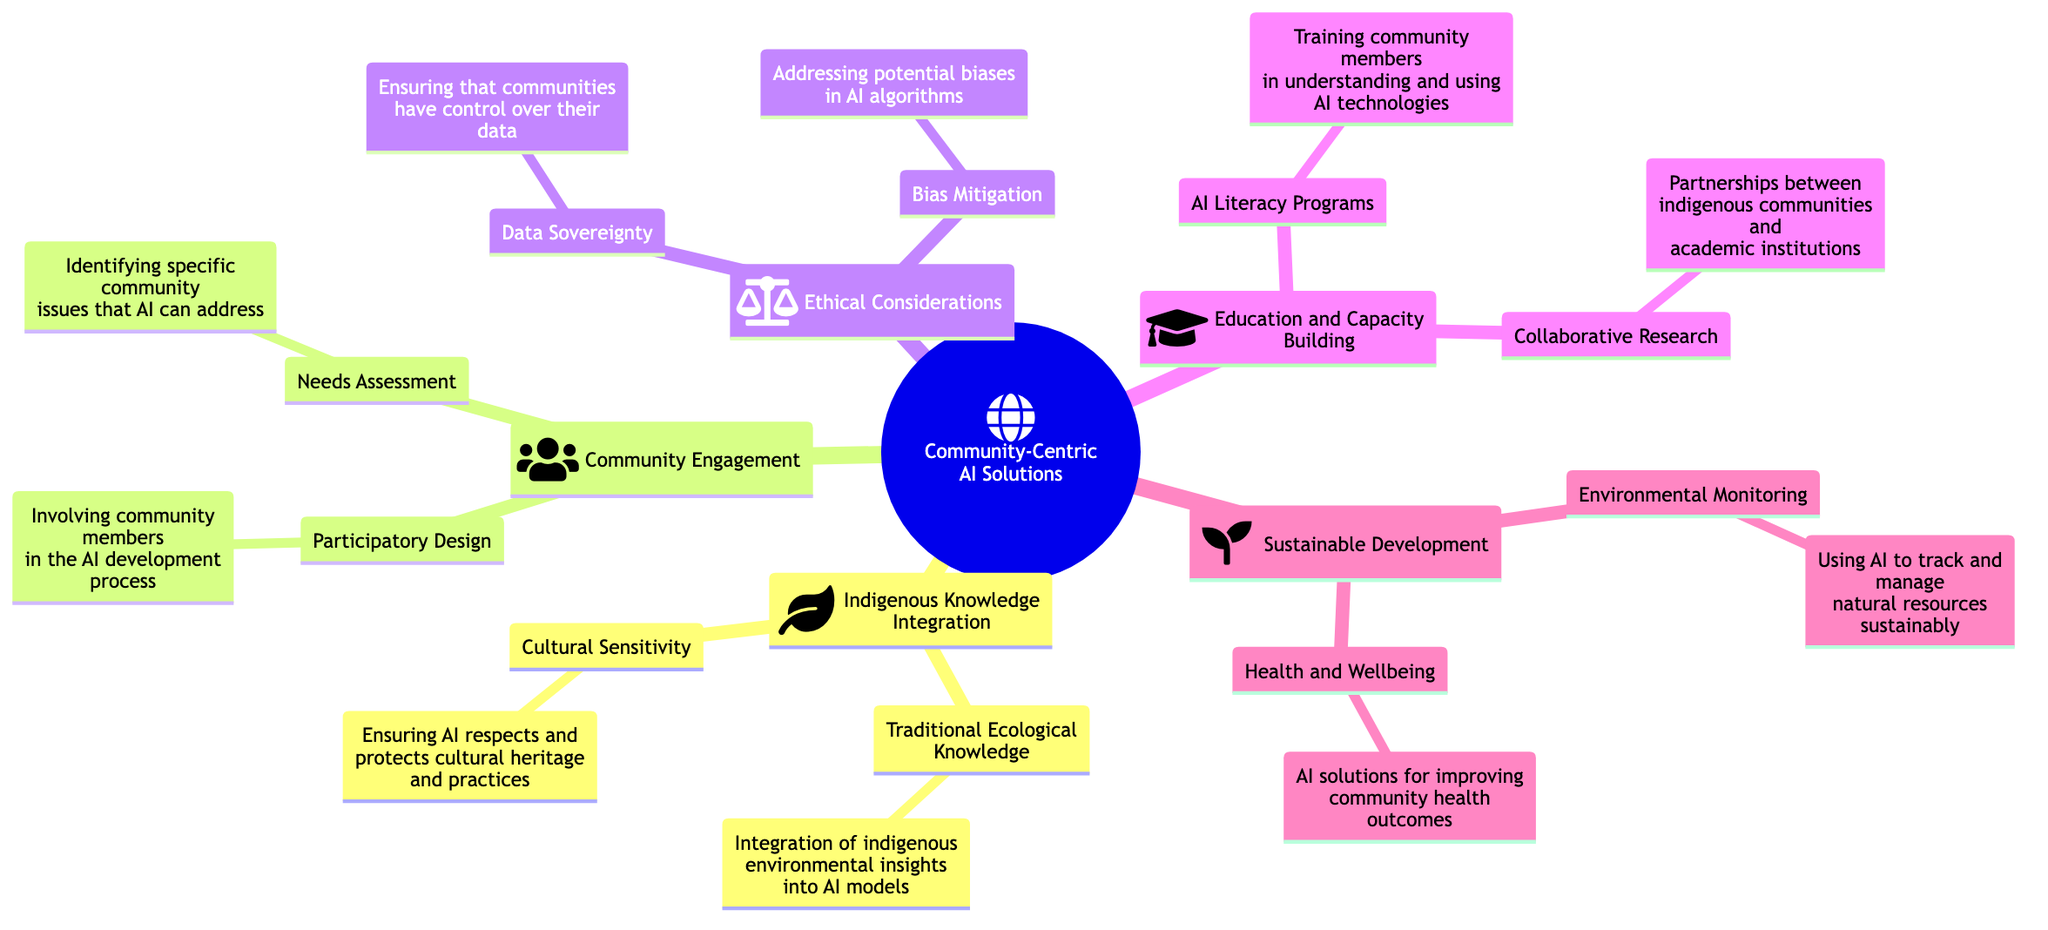What is the main topic of the mind map? The main topic is labeled at the root of the diagram as "Community-Centric AI Solutions: Tailoring Technology to Address Indigenous Needs".
Answer: Community-Centric AI Solutions: Tailoring Technology to Address Indigenous Needs How many primary elements are there in the diagram? There are five primary elements branching out from the main topic. They are Indigenous Knowledge Integration, Community Engagement, Ethical Considerations, Education and Capacity Building, and Sustainable Development.
Answer: 5 What is the detail associated with "Traditional Ecological Knowledge"? The detail states that it involves "Integration of indigenous environmental insights into AI models".
Answer: Integration of indigenous environmental insights into AI models Which subelement focuses on community members' involvement in AI development? The subelement pertaining to community involvement is "Participatory Design".
Answer: Participatory Design What is the relationship between "Data Sovereignty" and "Bias Mitigation"? Both "Data Sovereignty" and "Bias Mitigation" are categorized under the same primary element, "Ethical Considerations", indicating they are part of the ethical framework for community-centric AI solutions.
Answer: Ethical Considerations How does "AI Literacy Programs" contribute to community capacity? "AI Literacy Programs" are aimed at training community members, enhancing their understanding and ability to use AI technologies, which builds overall community capacity.
Answer: Training community members in understanding and using AI technologies Identify a subelement that relates to environmental concerns. "Environmental Monitoring" is a subelement that directly relates to environmental concerns by focusing on using AI to manage natural resources sustainably.
Answer: Environmental Monitoring What two areas are addressed under the Sustainable Development element? The two areas addressed are "Environmental Monitoring" and "Health and Wellbeing".
Answer: Environmental Monitoring, Health and Wellbeing What is the common goal shared by "Health and Wellbeing" and "Traditional Ecological Knowledge"? Both aim to enhance community outcomes; "Health and Wellbeing" seeks to improve health, while "Traditional Ecological Knowledge" integrates environmental insights for sustainable practices, collectively enhancing community welfare.
Answer: Enhancing community outcomes What type of partnerships are mentioned under "Collaborative Research"? The partnerships highlighted are between indigenous communities and academic institutions, indicating collaborative efforts for research.
Answer: Partnerships between indigenous communities and academic institutions 